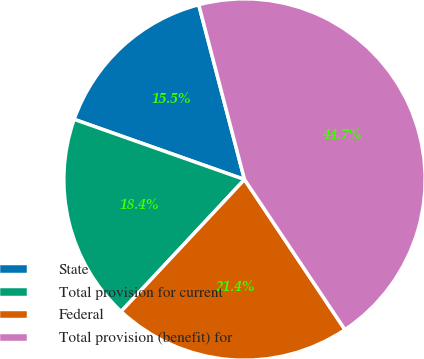Convert chart to OTSL. <chart><loc_0><loc_0><loc_500><loc_500><pie_chart><fcel>State<fcel>Total provision for current<fcel>Federal<fcel>Total provision (benefit) for<nl><fcel>15.52%<fcel>18.44%<fcel>21.35%<fcel>44.69%<nl></chart> 